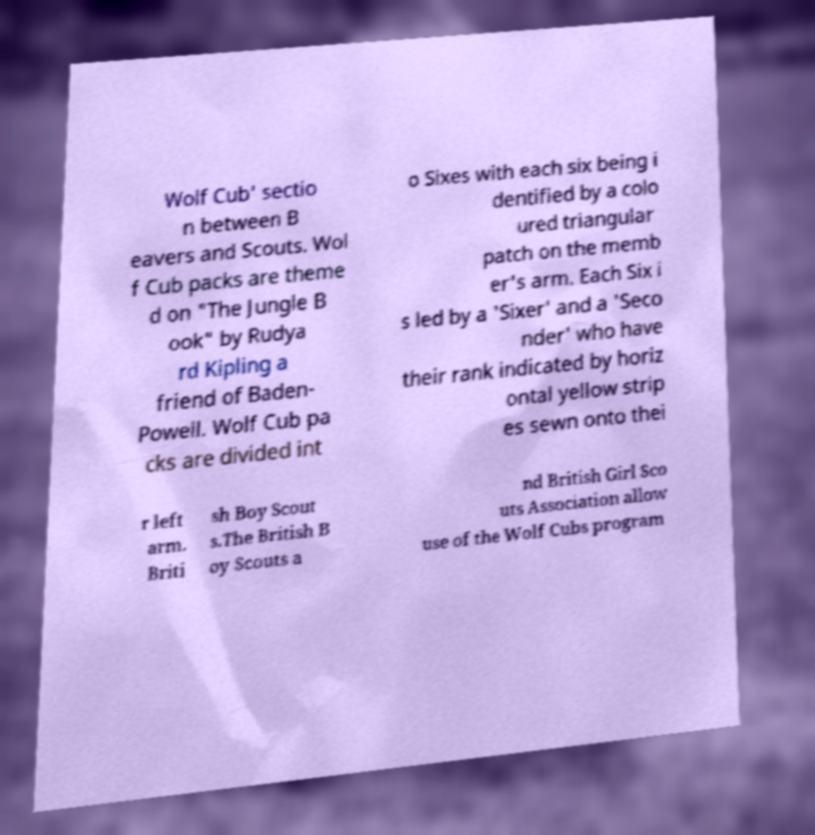Could you extract and type out the text from this image? Wolf Cub' sectio n between B eavers and Scouts. Wol f Cub packs are theme d on "The Jungle B ook" by Rudya rd Kipling a friend of Baden- Powell. Wolf Cub pa cks are divided int o Sixes with each six being i dentified by a colo ured triangular patch on the memb er's arm. Each Six i s led by a 'Sixer' and a 'Seco nder' who have their rank indicated by horiz ontal yellow strip es sewn onto thei r left arm. Briti sh Boy Scout s.The British B oy Scouts a nd British Girl Sco uts Association allow use of the Wolf Cubs program 